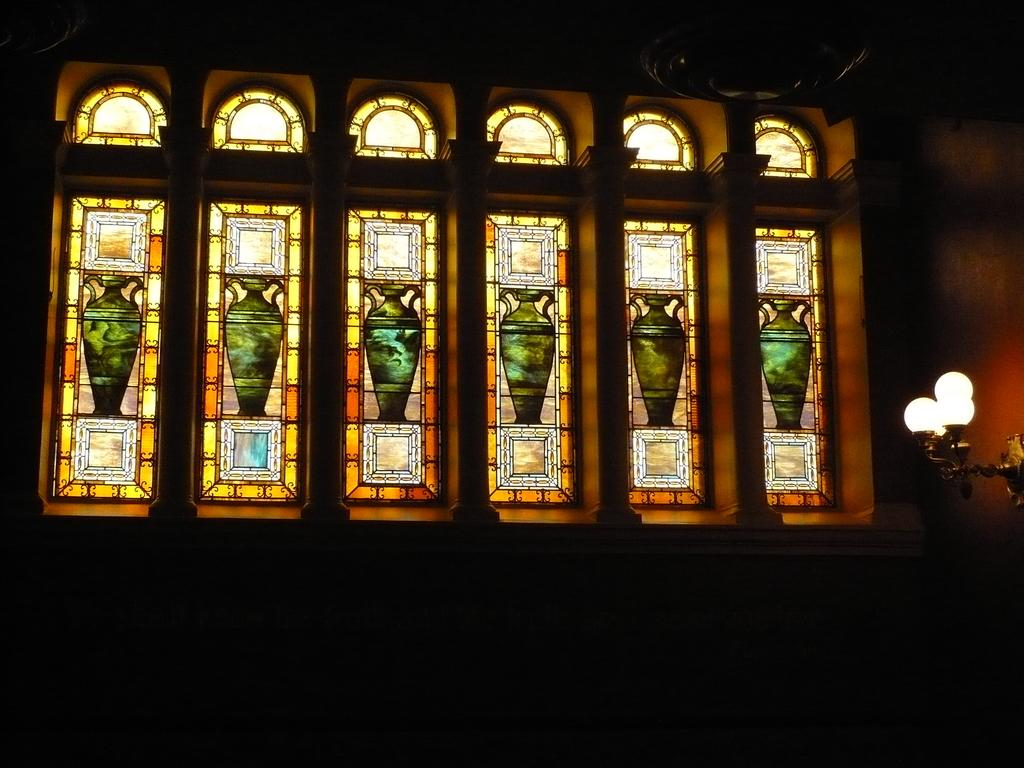What is a prominent feature in the image? There is a wall in the image. What can be seen on the wall? The wall has windows. What is unique about the windows? Pictures are painted on the windows. Is there any other object attached to the wall? Yes, a lamp is attached to the wall on the right side. What type of animals can be seen in the zoo through the windows in the image? There is no zoo present in the image, and the windows have pictures painted on them, not views of a zoo. 